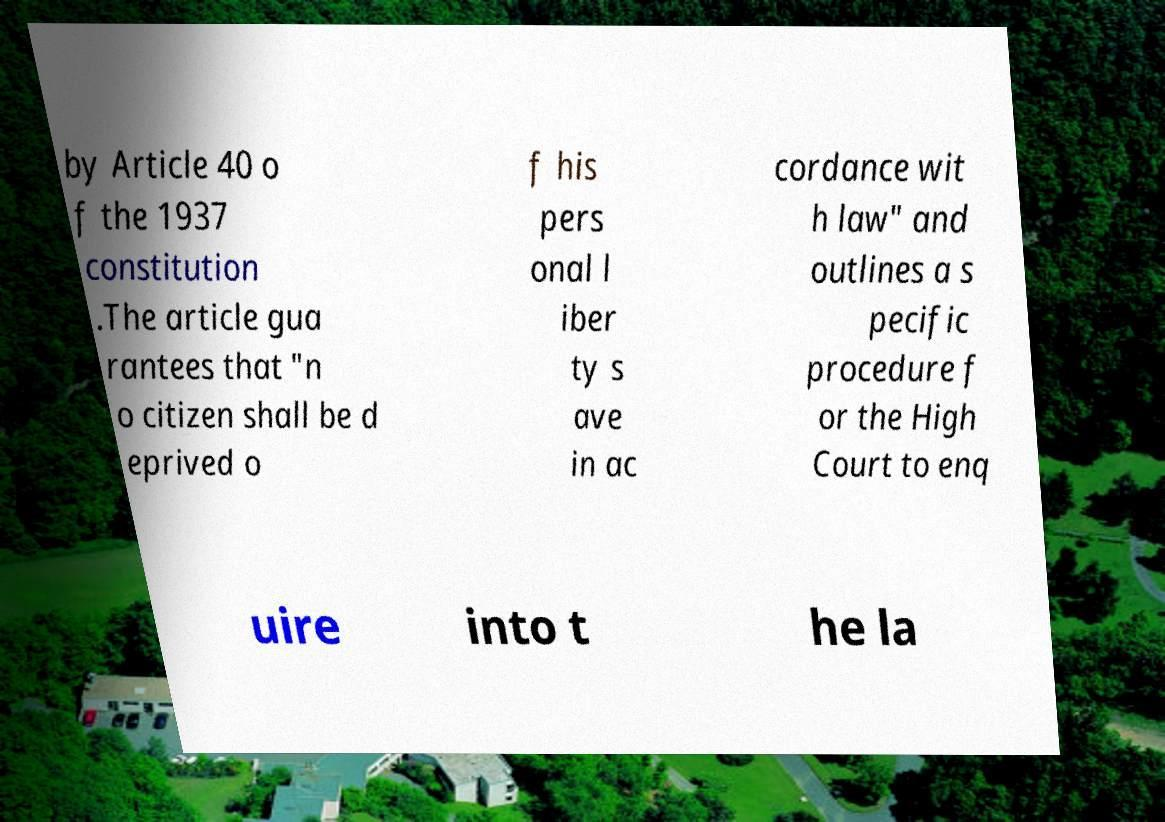Can you accurately transcribe the text from the provided image for me? by Article 40 o f the 1937 constitution .The article gua rantees that "n o citizen shall be d eprived o f his pers onal l iber ty s ave in ac cordance wit h law" and outlines a s pecific procedure f or the High Court to enq uire into t he la 